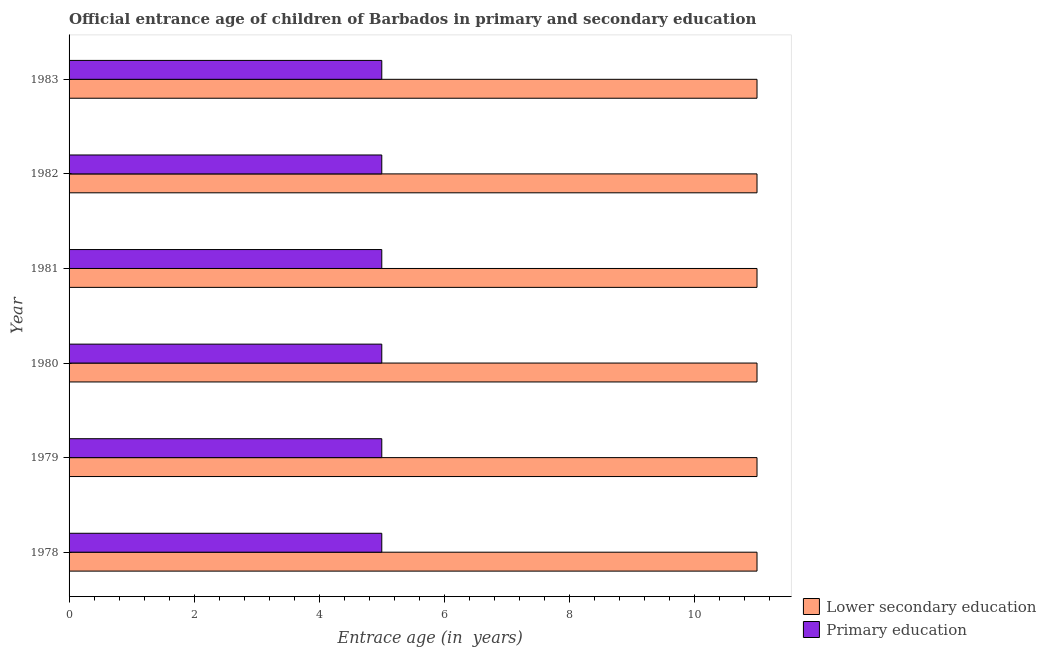How many different coloured bars are there?
Your answer should be compact. 2. How many groups of bars are there?
Offer a very short reply. 6. Are the number of bars on each tick of the Y-axis equal?
Offer a very short reply. Yes. What is the label of the 2nd group of bars from the top?
Your response must be concise. 1982. In how many cases, is the number of bars for a given year not equal to the number of legend labels?
Keep it short and to the point. 0. What is the entrance age of chiildren in primary education in 1981?
Make the answer very short. 5. Across all years, what is the maximum entrance age of chiildren in primary education?
Make the answer very short. 5. Across all years, what is the minimum entrance age of children in lower secondary education?
Offer a very short reply. 11. In which year was the entrance age of children in lower secondary education maximum?
Make the answer very short. 1978. In which year was the entrance age of children in lower secondary education minimum?
Make the answer very short. 1978. What is the total entrance age of chiildren in primary education in the graph?
Keep it short and to the point. 30. What is the difference between the entrance age of children in lower secondary education in 1981 and that in 1982?
Provide a succinct answer. 0. What is the difference between the entrance age of children in lower secondary education in 1981 and the entrance age of chiildren in primary education in 1982?
Provide a short and direct response. 6. In the year 1981, what is the difference between the entrance age of children in lower secondary education and entrance age of chiildren in primary education?
Offer a very short reply. 6. In how many years, is the entrance age of chiildren in primary education greater than 1.2000000000000002 years?
Your answer should be very brief. 6. What is the ratio of the entrance age of children in lower secondary education in 1978 to that in 1980?
Make the answer very short. 1. Is the sum of the entrance age of children in lower secondary education in 1978 and 1981 greater than the maximum entrance age of chiildren in primary education across all years?
Give a very brief answer. Yes. What does the 2nd bar from the top in 1981 represents?
Offer a terse response. Lower secondary education. How many bars are there?
Offer a very short reply. 12. Are all the bars in the graph horizontal?
Keep it short and to the point. Yes. How many years are there in the graph?
Offer a terse response. 6. Are the values on the major ticks of X-axis written in scientific E-notation?
Keep it short and to the point. No. Does the graph contain any zero values?
Offer a very short reply. No. Does the graph contain grids?
Ensure brevity in your answer.  No. Where does the legend appear in the graph?
Your answer should be very brief. Bottom right. How many legend labels are there?
Your answer should be very brief. 2. What is the title of the graph?
Give a very brief answer. Official entrance age of children of Barbados in primary and secondary education. Does "Revenue" appear as one of the legend labels in the graph?
Your answer should be very brief. No. What is the label or title of the X-axis?
Provide a succinct answer. Entrace age (in  years). What is the Entrace age (in  years) of Lower secondary education in 1978?
Make the answer very short. 11. What is the Entrace age (in  years) of Primary education in 1978?
Offer a very short reply. 5. What is the Entrace age (in  years) of Lower secondary education in 1979?
Provide a short and direct response. 11. What is the Entrace age (in  years) in Lower secondary education in 1981?
Your response must be concise. 11. What is the Entrace age (in  years) in Lower secondary education in 1982?
Your answer should be compact. 11. What is the Entrace age (in  years) of Primary education in 1982?
Provide a short and direct response. 5. What is the Entrace age (in  years) of Lower secondary education in 1983?
Ensure brevity in your answer.  11. Across all years, what is the maximum Entrace age (in  years) of Lower secondary education?
Keep it short and to the point. 11. Across all years, what is the maximum Entrace age (in  years) in Primary education?
Offer a terse response. 5. Across all years, what is the minimum Entrace age (in  years) of Lower secondary education?
Offer a very short reply. 11. What is the total Entrace age (in  years) in Lower secondary education in the graph?
Your answer should be compact. 66. What is the difference between the Entrace age (in  years) in Lower secondary education in 1978 and that in 1979?
Make the answer very short. 0. What is the difference between the Entrace age (in  years) of Primary education in 1978 and that in 1979?
Give a very brief answer. 0. What is the difference between the Entrace age (in  years) in Lower secondary education in 1978 and that in 1980?
Ensure brevity in your answer.  0. What is the difference between the Entrace age (in  years) of Primary education in 1978 and that in 1980?
Keep it short and to the point. 0. What is the difference between the Entrace age (in  years) in Lower secondary education in 1978 and that in 1981?
Offer a terse response. 0. What is the difference between the Entrace age (in  years) in Primary education in 1978 and that in 1981?
Your answer should be compact. 0. What is the difference between the Entrace age (in  years) in Lower secondary education in 1978 and that in 1982?
Make the answer very short. 0. What is the difference between the Entrace age (in  years) of Primary education in 1979 and that in 1980?
Your answer should be very brief. 0. What is the difference between the Entrace age (in  years) of Primary education in 1979 and that in 1981?
Provide a short and direct response. 0. What is the difference between the Entrace age (in  years) of Lower secondary education in 1979 and that in 1982?
Your response must be concise. 0. What is the difference between the Entrace age (in  years) of Primary education in 1980 and that in 1981?
Keep it short and to the point. 0. What is the difference between the Entrace age (in  years) in Primary education in 1980 and that in 1982?
Provide a succinct answer. 0. What is the difference between the Entrace age (in  years) of Primary education in 1980 and that in 1983?
Make the answer very short. 0. What is the difference between the Entrace age (in  years) of Lower secondary education in 1981 and that in 1983?
Ensure brevity in your answer.  0. What is the difference between the Entrace age (in  years) of Primary education in 1981 and that in 1983?
Provide a short and direct response. 0. What is the difference between the Entrace age (in  years) in Lower secondary education in 1982 and that in 1983?
Offer a terse response. 0. What is the difference between the Entrace age (in  years) in Primary education in 1982 and that in 1983?
Give a very brief answer. 0. What is the difference between the Entrace age (in  years) in Lower secondary education in 1978 and the Entrace age (in  years) in Primary education in 1982?
Your response must be concise. 6. What is the difference between the Entrace age (in  years) of Lower secondary education in 1979 and the Entrace age (in  years) of Primary education in 1981?
Ensure brevity in your answer.  6. What is the difference between the Entrace age (in  years) of Lower secondary education in 1979 and the Entrace age (in  years) of Primary education in 1982?
Your answer should be compact. 6. What is the difference between the Entrace age (in  years) in Lower secondary education in 1980 and the Entrace age (in  years) in Primary education in 1982?
Give a very brief answer. 6. What is the difference between the Entrace age (in  years) of Lower secondary education in 1981 and the Entrace age (in  years) of Primary education in 1983?
Give a very brief answer. 6. What is the difference between the Entrace age (in  years) in Lower secondary education in 1982 and the Entrace age (in  years) in Primary education in 1983?
Offer a very short reply. 6. In the year 1979, what is the difference between the Entrace age (in  years) in Lower secondary education and Entrace age (in  years) in Primary education?
Your answer should be very brief. 6. In the year 1983, what is the difference between the Entrace age (in  years) in Lower secondary education and Entrace age (in  years) in Primary education?
Provide a short and direct response. 6. What is the ratio of the Entrace age (in  years) of Primary education in 1978 to that in 1980?
Your response must be concise. 1. What is the ratio of the Entrace age (in  years) in Primary education in 1978 to that in 1982?
Give a very brief answer. 1. What is the ratio of the Entrace age (in  years) of Primary education in 1979 to that in 1980?
Your answer should be compact. 1. What is the ratio of the Entrace age (in  years) in Lower secondary education in 1979 to that in 1982?
Your answer should be very brief. 1. What is the ratio of the Entrace age (in  years) in Lower secondary education in 1980 to that in 1981?
Offer a very short reply. 1. What is the ratio of the Entrace age (in  years) of Primary education in 1980 to that in 1982?
Keep it short and to the point. 1. What is the ratio of the Entrace age (in  years) in Lower secondary education in 1980 to that in 1983?
Provide a short and direct response. 1. What is the ratio of the Entrace age (in  years) in Primary education in 1980 to that in 1983?
Make the answer very short. 1. What is the ratio of the Entrace age (in  years) in Lower secondary education in 1981 to that in 1982?
Give a very brief answer. 1. What is the ratio of the Entrace age (in  years) in Lower secondary education in 1982 to that in 1983?
Give a very brief answer. 1. What is the difference between the highest and the second highest Entrace age (in  years) of Lower secondary education?
Your response must be concise. 0. What is the difference between the highest and the second highest Entrace age (in  years) of Primary education?
Your answer should be compact. 0. 